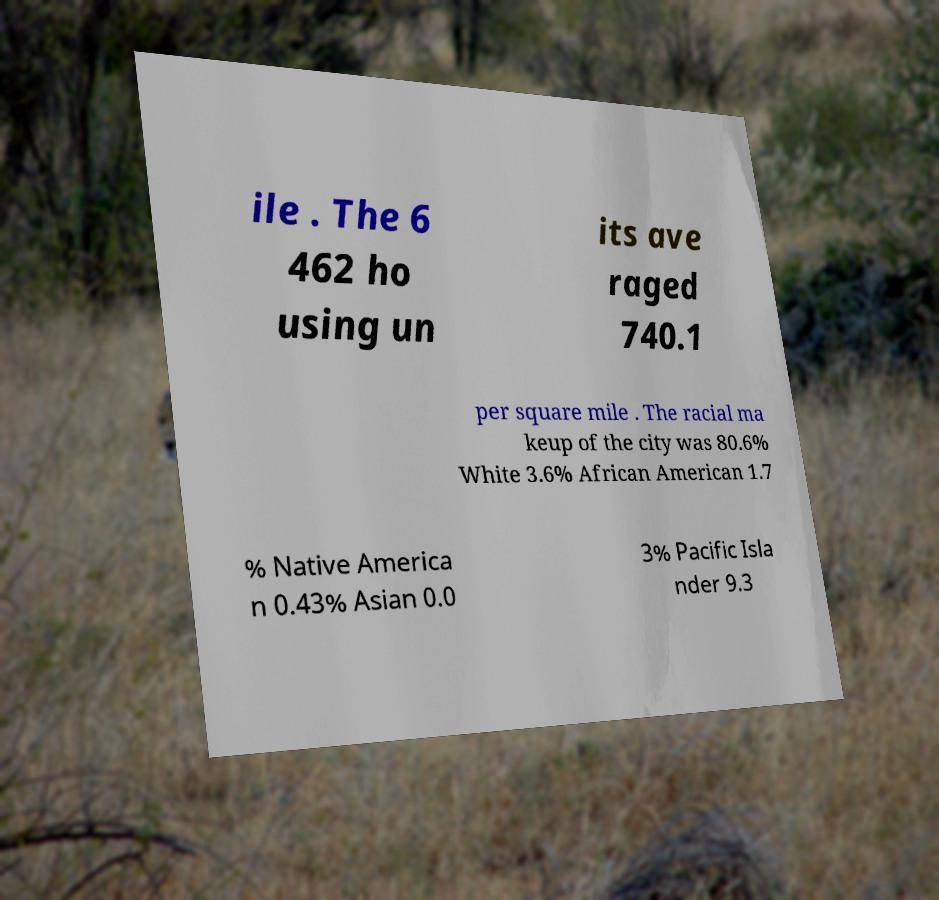Could you extract and type out the text from this image? ile . The 6 462 ho using un its ave raged 740.1 per square mile . The racial ma keup of the city was 80.6% White 3.6% African American 1.7 % Native America n 0.43% Asian 0.0 3% Pacific Isla nder 9.3 